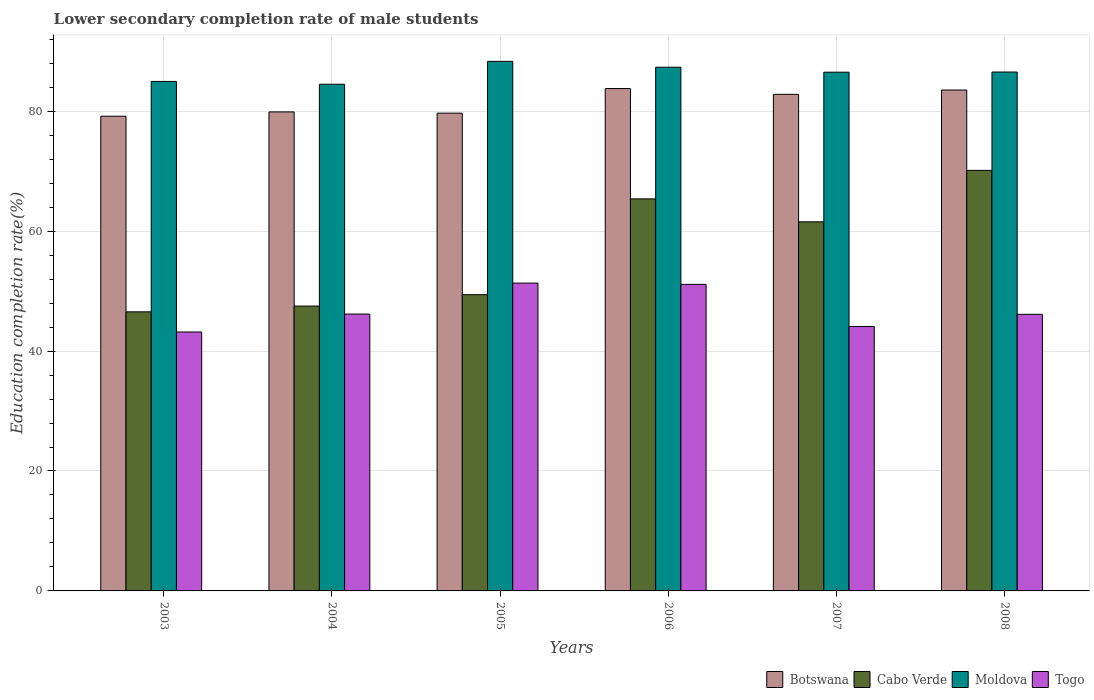How many different coloured bars are there?
Provide a succinct answer. 4. Are the number of bars per tick equal to the number of legend labels?
Keep it short and to the point. Yes. How many bars are there on the 1st tick from the left?
Your response must be concise. 4. How many bars are there on the 5th tick from the right?
Offer a terse response. 4. In how many cases, is the number of bars for a given year not equal to the number of legend labels?
Provide a short and direct response. 0. What is the lower secondary completion rate of male students in Togo in 2006?
Your answer should be compact. 51.13. Across all years, what is the maximum lower secondary completion rate of male students in Togo?
Provide a short and direct response. 51.34. Across all years, what is the minimum lower secondary completion rate of male students in Cabo Verde?
Provide a short and direct response. 46.54. What is the total lower secondary completion rate of male students in Botswana in the graph?
Give a very brief answer. 488.87. What is the difference between the lower secondary completion rate of male students in Moldova in 2006 and that in 2008?
Your answer should be compact. 0.8. What is the difference between the lower secondary completion rate of male students in Botswana in 2007 and the lower secondary completion rate of male students in Moldova in 2004?
Offer a terse response. -1.68. What is the average lower secondary completion rate of male students in Moldova per year?
Provide a short and direct response. 86.36. In the year 2003, what is the difference between the lower secondary completion rate of male students in Moldova and lower secondary completion rate of male students in Cabo Verde?
Your answer should be very brief. 38.43. What is the ratio of the lower secondary completion rate of male students in Cabo Verde in 2004 to that in 2007?
Your answer should be very brief. 0.77. Is the lower secondary completion rate of male students in Togo in 2004 less than that in 2005?
Your response must be concise. Yes. Is the difference between the lower secondary completion rate of male students in Moldova in 2005 and 2007 greater than the difference between the lower secondary completion rate of male students in Cabo Verde in 2005 and 2007?
Offer a terse response. Yes. What is the difference between the highest and the second highest lower secondary completion rate of male students in Botswana?
Provide a succinct answer. 0.25. What is the difference between the highest and the lowest lower secondary completion rate of male students in Moldova?
Offer a terse response. 3.82. Is the sum of the lower secondary completion rate of male students in Togo in 2006 and 2008 greater than the maximum lower secondary completion rate of male students in Moldova across all years?
Provide a succinct answer. Yes. What does the 3rd bar from the left in 2004 represents?
Offer a very short reply. Moldova. What does the 4th bar from the right in 2007 represents?
Provide a succinct answer. Botswana. Is it the case that in every year, the sum of the lower secondary completion rate of male students in Togo and lower secondary completion rate of male students in Cabo Verde is greater than the lower secondary completion rate of male students in Moldova?
Offer a terse response. Yes. How many bars are there?
Your answer should be compact. 24. Are all the bars in the graph horizontal?
Your answer should be compact. No. How many years are there in the graph?
Offer a terse response. 6. Are the values on the major ticks of Y-axis written in scientific E-notation?
Give a very brief answer. No. Does the graph contain any zero values?
Offer a very short reply. No. Where does the legend appear in the graph?
Provide a short and direct response. Bottom right. How many legend labels are there?
Your response must be concise. 4. How are the legend labels stacked?
Offer a very short reply. Horizontal. What is the title of the graph?
Provide a short and direct response. Lower secondary completion rate of male students. Does "St. Lucia" appear as one of the legend labels in the graph?
Your response must be concise. No. What is the label or title of the X-axis?
Provide a succinct answer. Years. What is the label or title of the Y-axis?
Ensure brevity in your answer.  Education completion rate(%). What is the Education completion rate(%) in Botswana in 2003?
Make the answer very short. 79.17. What is the Education completion rate(%) of Cabo Verde in 2003?
Provide a short and direct response. 46.54. What is the Education completion rate(%) of Moldova in 2003?
Ensure brevity in your answer.  84.97. What is the Education completion rate(%) of Togo in 2003?
Give a very brief answer. 43.18. What is the Education completion rate(%) of Botswana in 2004?
Give a very brief answer. 79.89. What is the Education completion rate(%) of Cabo Verde in 2004?
Your response must be concise. 47.51. What is the Education completion rate(%) in Moldova in 2004?
Ensure brevity in your answer.  84.5. What is the Education completion rate(%) of Togo in 2004?
Offer a terse response. 46.17. What is the Education completion rate(%) in Botswana in 2005?
Offer a terse response. 79.68. What is the Education completion rate(%) of Cabo Verde in 2005?
Keep it short and to the point. 49.41. What is the Education completion rate(%) of Moldova in 2005?
Give a very brief answer. 88.32. What is the Education completion rate(%) in Togo in 2005?
Ensure brevity in your answer.  51.34. What is the Education completion rate(%) in Botswana in 2006?
Offer a terse response. 83.78. What is the Education completion rate(%) of Cabo Verde in 2006?
Provide a short and direct response. 65.38. What is the Education completion rate(%) of Moldova in 2006?
Provide a short and direct response. 87.34. What is the Education completion rate(%) in Togo in 2006?
Your answer should be very brief. 51.13. What is the Education completion rate(%) in Botswana in 2007?
Your response must be concise. 82.82. What is the Education completion rate(%) of Cabo Verde in 2007?
Provide a succinct answer. 61.55. What is the Education completion rate(%) of Moldova in 2007?
Keep it short and to the point. 86.51. What is the Education completion rate(%) in Togo in 2007?
Your response must be concise. 44.1. What is the Education completion rate(%) of Botswana in 2008?
Your answer should be very brief. 83.54. What is the Education completion rate(%) of Cabo Verde in 2008?
Keep it short and to the point. 70.13. What is the Education completion rate(%) of Moldova in 2008?
Keep it short and to the point. 86.53. What is the Education completion rate(%) in Togo in 2008?
Offer a very short reply. 46.13. Across all years, what is the maximum Education completion rate(%) of Botswana?
Make the answer very short. 83.78. Across all years, what is the maximum Education completion rate(%) in Cabo Verde?
Keep it short and to the point. 70.13. Across all years, what is the maximum Education completion rate(%) of Moldova?
Make the answer very short. 88.32. Across all years, what is the maximum Education completion rate(%) of Togo?
Your response must be concise. 51.34. Across all years, what is the minimum Education completion rate(%) in Botswana?
Provide a short and direct response. 79.17. Across all years, what is the minimum Education completion rate(%) of Cabo Verde?
Keep it short and to the point. 46.54. Across all years, what is the minimum Education completion rate(%) of Moldova?
Your answer should be very brief. 84.5. Across all years, what is the minimum Education completion rate(%) in Togo?
Your response must be concise. 43.18. What is the total Education completion rate(%) in Botswana in the graph?
Your response must be concise. 488.87. What is the total Education completion rate(%) in Cabo Verde in the graph?
Ensure brevity in your answer.  340.53. What is the total Education completion rate(%) in Moldova in the graph?
Make the answer very short. 518.17. What is the total Education completion rate(%) of Togo in the graph?
Provide a short and direct response. 282.05. What is the difference between the Education completion rate(%) in Botswana in 2003 and that in 2004?
Make the answer very short. -0.72. What is the difference between the Education completion rate(%) in Cabo Verde in 2003 and that in 2004?
Offer a very short reply. -0.96. What is the difference between the Education completion rate(%) of Moldova in 2003 and that in 2004?
Offer a terse response. 0.47. What is the difference between the Education completion rate(%) of Togo in 2003 and that in 2004?
Keep it short and to the point. -2.99. What is the difference between the Education completion rate(%) of Botswana in 2003 and that in 2005?
Your answer should be compact. -0.51. What is the difference between the Education completion rate(%) in Cabo Verde in 2003 and that in 2005?
Your answer should be compact. -2.86. What is the difference between the Education completion rate(%) in Moldova in 2003 and that in 2005?
Ensure brevity in your answer.  -3.35. What is the difference between the Education completion rate(%) in Togo in 2003 and that in 2005?
Keep it short and to the point. -8.15. What is the difference between the Education completion rate(%) in Botswana in 2003 and that in 2006?
Make the answer very short. -4.61. What is the difference between the Education completion rate(%) in Cabo Verde in 2003 and that in 2006?
Make the answer very short. -18.84. What is the difference between the Education completion rate(%) in Moldova in 2003 and that in 2006?
Provide a short and direct response. -2.37. What is the difference between the Education completion rate(%) of Togo in 2003 and that in 2006?
Ensure brevity in your answer.  -7.94. What is the difference between the Education completion rate(%) of Botswana in 2003 and that in 2007?
Ensure brevity in your answer.  -3.65. What is the difference between the Education completion rate(%) of Cabo Verde in 2003 and that in 2007?
Give a very brief answer. -15.01. What is the difference between the Education completion rate(%) in Moldova in 2003 and that in 2007?
Keep it short and to the point. -1.54. What is the difference between the Education completion rate(%) of Togo in 2003 and that in 2007?
Make the answer very short. -0.92. What is the difference between the Education completion rate(%) of Botswana in 2003 and that in 2008?
Your answer should be very brief. -4.37. What is the difference between the Education completion rate(%) of Cabo Verde in 2003 and that in 2008?
Provide a short and direct response. -23.59. What is the difference between the Education completion rate(%) of Moldova in 2003 and that in 2008?
Your response must be concise. -1.56. What is the difference between the Education completion rate(%) in Togo in 2003 and that in 2008?
Provide a short and direct response. -2.95. What is the difference between the Education completion rate(%) in Botswana in 2004 and that in 2005?
Give a very brief answer. 0.21. What is the difference between the Education completion rate(%) of Cabo Verde in 2004 and that in 2005?
Make the answer very short. -1.9. What is the difference between the Education completion rate(%) in Moldova in 2004 and that in 2005?
Make the answer very short. -3.82. What is the difference between the Education completion rate(%) in Togo in 2004 and that in 2005?
Your answer should be compact. -5.17. What is the difference between the Education completion rate(%) of Botswana in 2004 and that in 2006?
Make the answer very short. -3.9. What is the difference between the Education completion rate(%) in Cabo Verde in 2004 and that in 2006?
Offer a very short reply. -17.87. What is the difference between the Education completion rate(%) in Moldova in 2004 and that in 2006?
Your answer should be compact. -2.84. What is the difference between the Education completion rate(%) in Togo in 2004 and that in 2006?
Make the answer very short. -4.95. What is the difference between the Education completion rate(%) of Botswana in 2004 and that in 2007?
Ensure brevity in your answer.  -2.93. What is the difference between the Education completion rate(%) in Cabo Verde in 2004 and that in 2007?
Provide a succinct answer. -14.05. What is the difference between the Education completion rate(%) in Moldova in 2004 and that in 2007?
Keep it short and to the point. -2.01. What is the difference between the Education completion rate(%) in Togo in 2004 and that in 2007?
Make the answer very short. 2.07. What is the difference between the Education completion rate(%) of Botswana in 2004 and that in 2008?
Offer a terse response. -3.65. What is the difference between the Education completion rate(%) of Cabo Verde in 2004 and that in 2008?
Ensure brevity in your answer.  -22.62. What is the difference between the Education completion rate(%) of Moldova in 2004 and that in 2008?
Your answer should be compact. -2.04. What is the difference between the Education completion rate(%) in Togo in 2004 and that in 2008?
Offer a very short reply. 0.04. What is the difference between the Education completion rate(%) of Botswana in 2005 and that in 2006?
Offer a terse response. -4.1. What is the difference between the Education completion rate(%) in Cabo Verde in 2005 and that in 2006?
Ensure brevity in your answer.  -15.97. What is the difference between the Education completion rate(%) of Moldova in 2005 and that in 2006?
Your answer should be very brief. 0.98. What is the difference between the Education completion rate(%) in Togo in 2005 and that in 2006?
Make the answer very short. 0.21. What is the difference between the Education completion rate(%) in Botswana in 2005 and that in 2007?
Offer a terse response. -3.14. What is the difference between the Education completion rate(%) in Cabo Verde in 2005 and that in 2007?
Give a very brief answer. -12.15. What is the difference between the Education completion rate(%) in Moldova in 2005 and that in 2007?
Offer a very short reply. 1.81. What is the difference between the Education completion rate(%) in Togo in 2005 and that in 2007?
Keep it short and to the point. 7.24. What is the difference between the Education completion rate(%) in Botswana in 2005 and that in 2008?
Your answer should be compact. -3.86. What is the difference between the Education completion rate(%) of Cabo Verde in 2005 and that in 2008?
Give a very brief answer. -20.73. What is the difference between the Education completion rate(%) in Moldova in 2005 and that in 2008?
Your response must be concise. 1.78. What is the difference between the Education completion rate(%) in Togo in 2005 and that in 2008?
Provide a short and direct response. 5.21. What is the difference between the Education completion rate(%) of Botswana in 2006 and that in 2007?
Provide a short and direct response. 0.97. What is the difference between the Education completion rate(%) of Cabo Verde in 2006 and that in 2007?
Provide a short and direct response. 3.83. What is the difference between the Education completion rate(%) in Moldova in 2006 and that in 2007?
Make the answer very short. 0.83. What is the difference between the Education completion rate(%) of Togo in 2006 and that in 2007?
Ensure brevity in your answer.  7.02. What is the difference between the Education completion rate(%) in Botswana in 2006 and that in 2008?
Ensure brevity in your answer.  0.25. What is the difference between the Education completion rate(%) in Cabo Verde in 2006 and that in 2008?
Give a very brief answer. -4.75. What is the difference between the Education completion rate(%) of Moldova in 2006 and that in 2008?
Provide a succinct answer. 0.8. What is the difference between the Education completion rate(%) of Togo in 2006 and that in 2008?
Keep it short and to the point. 5. What is the difference between the Education completion rate(%) in Botswana in 2007 and that in 2008?
Make the answer very short. -0.72. What is the difference between the Education completion rate(%) in Cabo Verde in 2007 and that in 2008?
Offer a terse response. -8.58. What is the difference between the Education completion rate(%) in Moldova in 2007 and that in 2008?
Your answer should be very brief. -0.03. What is the difference between the Education completion rate(%) of Togo in 2007 and that in 2008?
Provide a short and direct response. -2.03. What is the difference between the Education completion rate(%) of Botswana in 2003 and the Education completion rate(%) of Cabo Verde in 2004?
Offer a terse response. 31.66. What is the difference between the Education completion rate(%) in Botswana in 2003 and the Education completion rate(%) in Moldova in 2004?
Your response must be concise. -5.33. What is the difference between the Education completion rate(%) in Botswana in 2003 and the Education completion rate(%) in Togo in 2004?
Provide a succinct answer. 33. What is the difference between the Education completion rate(%) of Cabo Verde in 2003 and the Education completion rate(%) of Moldova in 2004?
Give a very brief answer. -37.95. What is the difference between the Education completion rate(%) of Cabo Verde in 2003 and the Education completion rate(%) of Togo in 2004?
Offer a terse response. 0.37. What is the difference between the Education completion rate(%) of Moldova in 2003 and the Education completion rate(%) of Togo in 2004?
Your answer should be compact. 38.8. What is the difference between the Education completion rate(%) of Botswana in 2003 and the Education completion rate(%) of Cabo Verde in 2005?
Your response must be concise. 29.76. What is the difference between the Education completion rate(%) in Botswana in 2003 and the Education completion rate(%) in Moldova in 2005?
Your answer should be very brief. -9.15. What is the difference between the Education completion rate(%) of Botswana in 2003 and the Education completion rate(%) of Togo in 2005?
Ensure brevity in your answer.  27.83. What is the difference between the Education completion rate(%) in Cabo Verde in 2003 and the Education completion rate(%) in Moldova in 2005?
Your response must be concise. -41.77. What is the difference between the Education completion rate(%) of Cabo Verde in 2003 and the Education completion rate(%) of Togo in 2005?
Provide a short and direct response. -4.79. What is the difference between the Education completion rate(%) of Moldova in 2003 and the Education completion rate(%) of Togo in 2005?
Keep it short and to the point. 33.63. What is the difference between the Education completion rate(%) in Botswana in 2003 and the Education completion rate(%) in Cabo Verde in 2006?
Keep it short and to the point. 13.79. What is the difference between the Education completion rate(%) in Botswana in 2003 and the Education completion rate(%) in Moldova in 2006?
Provide a short and direct response. -8.17. What is the difference between the Education completion rate(%) in Botswana in 2003 and the Education completion rate(%) in Togo in 2006?
Offer a very short reply. 28.04. What is the difference between the Education completion rate(%) of Cabo Verde in 2003 and the Education completion rate(%) of Moldova in 2006?
Your response must be concise. -40.8. What is the difference between the Education completion rate(%) of Cabo Verde in 2003 and the Education completion rate(%) of Togo in 2006?
Provide a short and direct response. -4.58. What is the difference between the Education completion rate(%) of Moldova in 2003 and the Education completion rate(%) of Togo in 2006?
Give a very brief answer. 33.84. What is the difference between the Education completion rate(%) in Botswana in 2003 and the Education completion rate(%) in Cabo Verde in 2007?
Keep it short and to the point. 17.61. What is the difference between the Education completion rate(%) in Botswana in 2003 and the Education completion rate(%) in Moldova in 2007?
Your answer should be compact. -7.34. What is the difference between the Education completion rate(%) of Botswana in 2003 and the Education completion rate(%) of Togo in 2007?
Offer a very short reply. 35.07. What is the difference between the Education completion rate(%) in Cabo Verde in 2003 and the Education completion rate(%) in Moldova in 2007?
Offer a terse response. -39.97. What is the difference between the Education completion rate(%) in Cabo Verde in 2003 and the Education completion rate(%) in Togo in 2007?
Give a very brief answer. 2.44. What is the difference between the Education completion rate(%) in Moldova in 2003 and the Education completion rate(%) in Togo in 2007?
Keep it short and to the point. 40.87. What is the difference between the Education completion rate(%) in Botswana in 2003 and the Education completion rate(%) in Cabo Verde in 2008?
Provide a short and direct response. 9.04. What is the difference between the Education completion rate(%) of Botswana in 2003 and the Education completion rate(%) of Moldova in 2008?
Ensure brevity in your answer.  -7.37. What is the difference between the Education completion rate(%) of Botswana in 2003 and the Education completion rate(%) of Togo in 2008?
Make the answer very short. 33.04. What is the difference between the Education completion rate(%) in Cabo Verde in 2003 and the Education completion rate(%) in Moldova in 2008?
Make the answer very short. -39.99. What is the difference between the Education completion rate(%) in Cabo Verde in 2003 and the Education completion rate(%) in Togo in 2008?
Your answer should be very brief. 0.41. What is the difference between the Education completion rate(%) of Moldova in 2003 and the Education completion rate(%) of Togo in 2008?
Ensure brevity in your answer.  38.84. What is the difference between the Education completion rate(%) of Botswana in 2004 and the Education completion rate(%) of Cabo Verde in 2005?
Offer a very short reply. 30.48. What is the difference between the Education completion rate(%) of Botswana in 2004 and the Education completion rate(%) of Moldova in 2005?
Offer a terse response. -8.43. What is the difference between the Education completion rate(%) in Botswana in 2004 and the Education completion rate(%) in Togo in 2005?
Your answer should be compact. 28.55. What is the difference between the Education completion rate(%) in Cabo Verde in 2004 and the Education completion rate(%) in Moldova in 2005?
Make the answer very short. -40.81. What is the difference between the Education completion rate(%) in Cabo Verde in 2004 and the Education completion rate(%) in Togo in 2005?
Your response must be concise. -3.83. What is the difference between the Education completion rate(%) in Moldova in 2004 and the Education completion rate(%) in Togo in 2005?
Your answer should be very brief. 33.16. What is the difference between the Education completion rate(%) in Botswana in 2004 and the Education completion rate(%) in Cabo Verde in 2006?
Offer a terse response. 14.5. What is the difference between the Education completion rate(%) in Botswana in 2004 and the Education completion rate(%) in Moldova in 2006?
Give a very brief answer. -7.45. What is the difference between the Education completion rate(%) of Botswana in 2004 and the Education completion rate(%) of Togo in 2006?
Offer a very short reply. 28.76. What is the difference between the Education completion rate(%) in Cabo Verde in 2004 and the Education completion rate(%) in Moldova in 2006?
Your response must be concise. -39.83. What is the difference between the Education completion rate(%) in Cabo Verde in 2004 and the Education completion rate(%) in Togo in 2006?
Offer a terse response. -3.62. What is the difference between the Education completion rate(%) of Moldova in 2004 and the Education completion rate(%) of Togo in 2006?
Your response must be concise. 33.37. What is the difference between the Education completion rate(%) of Botswana in 2004 and the Education completion rate(%) of Cabo Verde in 2007?
Ensure brevity in your answer.  18.33. What is the difference between the Education completion rate(%) of Botswana in 2004 and the Education completion rate(%) of Moldova in 2007?
Your answer should be very brief. -6.62. What is the difference between the Education completion rate(%) in Botswana in 2004 and the Education completion rate(%) in Togo in 2007?
Your answer should be compact. 35.78. What is the difference between the Education completion rate(%) of Cabo Verde in 2004 and the Education completion rate(%) of Moldova in 2007?
Make the answer very short. -39. What is the difference between the Education completion rate(%) of Cabo Verde in 2004 and the Education completion rate(%) of Togo in 2007?
Your answer should be compact. 3.41. What is the difference between the Education completion rate(%) in Moldova in 2004 and the Education completion rate(%) in Togo in 2007?
Your answer should be very brief. 40.4. What is the difference between the Education completion rate(%) of Botswana in 2004 and the Education completion rate(%) of Cabo Verde in 2008?
Keep it short and to the point. 9.75. What is the difference between the Education completion rate(%) of Botswana in 2004 and the Education completion rate(%) of Moldova in 2008?
Your response must be concise. -6.65. What is the difference between the Education completion rate(%) in Botswana in 2004 and the Education completion rate(%) in Togo in 2008?
Provide a succinct answer. 33.76. What is the difference between the Education completion rate(%) in Cabo Verde in 2004 and the Education completion rate(%) in Moldova in 2008?
Make the answer very short. -39.03. What is the difference between the Education completion rate(%) of Cabo Verde in 2004 and the Education completion rate(%) of Togo in 2008?
Offer a terse response. 1.38. What is the difference between the Education completion rate(%) of Moldova in 2004 and the Education completion rate(%) of Togo in 2008?
Ensure brevity in your answer.  38.37. What is the difference between the Education completion rate(%) of Botswana in 2005 and the Education completion rate(%) of Cabo Verde in 2006?
Offer a very short reply. 14.3. What is the difference between the Education completion rate(%) in Botswana in 2005 and the Education completion rate(%) in Moldova in 2006?
Keep it short and to the point. -7.66. What is the difference between the Education completion rate(%) of Botswana in 2005 and the Education completion rate(%) of Togo in 2006?
Your answer should be very brief. 28.55. What is the difference between the Education completion rate(%) of Cabo Verde in 2005 and the Education completion rate(%) of Moldova in 2006?
Your answer should be compact. -37.93. What is the difference between the Education completion rate(%) of Cabo Verde in 2005 and the Education completion rate(%) of Togo in 2006?
Provide a short and direct response. -1.72. What is the difference between the Education completion rate(%) of Moldova in 2005 and the Education completion rate(%) of Togo in 2006?
Your response must be concise. 37.19. What is the difference between the Education completion rate(%) in Botswana in 2005 and the Education completion rate(%) in Cabo Verde in 2007?
Keep it short and to the point. 18.12. What is the difference between the Education completion rate(%) in Botswana in 2005 and the Education completion rate(%) in Moldova in 2007?
Offer a terse response. -6.83. What is the difference between the Education completion rate(%) of Botswana in 2005 and the Education completion rate(%) of Togo in 2007?
Give a very brief answer. 35.58. What is the difference between the Education completion rate(%) in Cabo Verde in 2005 and the Education completion rate(%) in Moldova in 2007?
Keep it short and to the point. -37.1. What is the difference between the Education completion rate(%) of Cabo Verde in 2005 and the Education completion rate(%) of Togo in 2007?
Ensure brevity in your answer.  5.31. What is the difference between the Education completion rate(%) in Moldova in 2005 and the Education completion rate(%) in Togo in 2007?
Give a very brief answer. 44.22. What is the difference between the Education completion rate(%) in Botswana in 2005 and the Education completion rate(%) in Cabo Verde in 2008?
Provide a succinct answer. 9.55. What is the difference between the Education completion rate(%) of Botswana in 2005 and the Education completion rate(%) of Moldova in 2008?
Ensure brevity in your answer.  -6.86. What is the difference between the Education completion rate(%) of Botswana in 2005 and the Education completion rate(%) of Togo in 2008?
Your answer should be very brief. 33.55. What is the difference between the Education completion rate(%) in Cabo Verde in 2005 and the Education completion rate(%) in Moldova in 2008?
Make the answer very short. -37.13. What is the difference between the Education completion rate(%) in Cabo Verde in 2005 and the Education completion rate(%) in Togo in 2008?
Offer a terse response. 3.28. What is the difference between the Education completion rate(%) of Moldova in 2005 and the Education completion rate(%) of Togo in 2008?
Give a very brief answer. 42.19. What is the difference between the Education completion rate(%) in Botswana in 2006 and the Education completion rate(%) in Cabo Verde in 2007?
Your answer should be compact. 22.23. What is the difference between the Education completion rate(%) in Botswana in 2006 and the Education completion rate(%) in Moldova in 2007?
Offer a terse response. -2.73. What is the difference between the Education completion rate(%) in Botswana in 2006 and the Education completion rate(%) in Togo in 2007?
Offer a terse response. 39.68. What is the difference between the Education completion rate(%) of Cabo Verde in 2006 and the Education completion rate(%) of Moldova in 2007?
Provide a short and direct response. -21.13. What is the difference between the Education completion rate(%) in Cabo Verde in 2006 and the Education completion rate(%) in Togo in 2007?
Make the answer very short. 21.28. What is the difference between the Education completion rate(%) of Moldova in 2006 and the Education completion rate(%) of Togo in 2007?
Offer a very short reply. 43.24. What is the difference between the Education completion rate(%) of Botswana in 2006 and the Education completion rate(%) of Cabo Verde in 2008?
Offer a terse response. 13.65. What is the difference between the Education completion rate(%) of Botswana in 2006 and the Education completion rate(%) of Moldova in 2008?
Your answer should be compact. -2.75. What is the difference between the Education completion rate(%) of Botswana in 2006 and the Education completion rate(%) of Togo in 2008?
Provide a succinct answer. 37.65. What is the difference between the Education completion rate(%) of Cabo Verde in 2006 and the Education completion rate(%) of Moldova in 2008?
Provide a succinct answer. -21.15. What is the difference between the Education completion rate(%) in Cabo Verde in 2006 and the Education completion rate(%) in Togo in 2008?
Offer a very short reply. 19.25. What is the difference between the Education completion rate(%) in Moldova in 2006 and the Education completion rate(%) in Togo in 2008?
Provide a short and direct response. 41.21. What is the difference between the Education completion rate(%) in Botswana in 2007 and the Education completion rate(%) in Cabo Verde in 2008?
Your response must be concise. 12.68. What is the difference between the Education completion rate(%) in Botswana in 2007 and the Education completion rate(%) in Moldova in 2008?
Ensure brevity in your answer.  -3.72. What is the difference between the Education completion rate(%) of Botswana in 2007 and the Education completion rate(%) of Togo in 2008?
Ensure brevity in your answer.  36.69. What is the difference between the Education completion rate(%) in Cabo Verde in 2007 and the Education completion rate(%) in Moldova in 2008?
Make the answer very short. -24.98. What is the difference between the Education completion rate(%) in Cabo Verde in 2007 and the Education completion rate(%) in Togo in 2008?
Your answer should be very brief. 15.43. What is the difference between the Education completion rate(%) of Moldova in 2007 and the Education completion rate(%) of Togo in 2008?
Your answer should be compact. 40.38. What is the average Education completion rate(%) in Botswana per year?
Your answer should be compact. 81.48. What is the average Education completion rate(%) of Cabo Verde per year?
Your answer should be very brief. 56.76. What is the average Education completion rate(%) of Moldova per year?
Provide a succinct answer. 86.36. What is the average Education completion rate(%) of Togo per year?
Give a very brief answer. 47.01. In the year 2003, what is the difference between the Education completion rate(%) in Botswana and Education completion rate(%) in Cabo Verde?
Your answer should be compact. 32.63. In the year 2003, what is the difference between the Education completion rate(%) in Botswana and Education completion rate(%) in Moldova?
Your response must be concise. -5.8. In the year 2003, what is the difference between the Education completion rate(%) in Botswana and Education completion rate(%) in Togo?
Provide a succinct answer. 35.99. In the year 2003, what is the difference between the Education completion rate(%) of Cabo Verde and Education completion rate(%) of Moldova?
Make the answer very short. -38.43. In the year 2003, what is the difference between the Education completion rate(%) in Cabo Verde and Education completion rate(%) in Togo?
Ensure brevity in your answer.  3.36. In the year 2003, what is the difference between the Education completion rate(%) in Moldova and Education completion rate(%) in Togo?
Your answer should be compact. 41.79. In the year 2004, what is the difference between the Education completion rate(%) of Botswana and Education completion rate(%) of Cabo Verde?
Your response must be concise. 32.38. In the year 2004, what is the difference between the Education completion rate(%) in Botswana and Education completion rate(%) in Moldova?
Give a very brief answer. -4.61. In the year 2004, what is the difference between the Education completion rate(%) of Botswana and Education completion rate(%) of Togo?
Give a very brief answer. 33.71. In the year 2004, what is the difference between the Education completion rate(%) of Cabo Verde and Education completion rate(%) of Moldova?
Ensure brevity in your answer.  -36.99. In the year 2004, what is the difference between the Education completion rate(%) of Cabo Verde and Education completion rate(%) of Togo?
Give a very brief answer. 1.34. In the year 2004, what is the difference between the Education completion rate(%) of Moldova and Education completion rate(%) of Togo?
Make the answer very short. 38.33. In the year 2005, what is the difference between the Education completion rate(%) of Botswana and Education completion rate(%) of Cabo Verde?
Provide a succinct answer. 30.27. In the year 2005, what is the difference between the Education completion rate(%) of Botswana and Education completion rate(%) of Moldova?
Ensure brevity in your answer.  -8.64. In the year 2005, what is the difference between the Education completion rate(%) of Botswana and Education completion rate(%) of Togo?
Provide a short and direct response. 28.34. In the year 2005, what is the difference between the Education completion rate(%) in Cabo Verde and Education completion rate(%) in Moldova?
Offer a very short reply. -38.91. In the year 2005, what is the difference between the Education completion rate(%) in Cabo Verde and Education completion rate(%) in Togo?
Your response must be concise. -1.93. In the year 2005, what is the difference between the Education completion rate(%) in Moldova and Education completion rate(%) in Togo?
Give a very brief answer. 36.98. In the year 2006, what is the difference between the Education completion rate(%) of Botswana and Education completion rate(%) of Cabo Verde?
Offer a terse response. 18.4. In the year 2006, what is the difference between the Education completion rate(%) in Botswana and Education completion rate(%) in Moldova?
Give a very brief answer. -3.56. In the year 2006, what is the difference between the Education completion rate(%) of Botswana and Education completion rate(%) of Togo?
Ensure brevity in your answer.  32.66. In the year 2006, what is the difference between the Education completion rate(%) in Cabo Verde and Education completion rate(%) in Moldova?
Ensure brevity in your answer.  -21.96. In the year 2006, what is the difference between the Education completion rate(%) of Cabo Verde and Education completion rate(%) of Togo?
Offer a very short reply. 14.26. In the year 2006, what is the difference between the Education completion rate(%) in Moldova and Education completion rate(%) in Togo?
Offer a terse response. 36.21. In the year 2007, what is the difference between the Education completion rate(%) of Botswana and Education completion rate(%) of Cabo Verde?
Your answer should be compact. 21.26. In the year 2007, what is the difference between the Education completion rate(%) in Botswana and Education completion rate(%) in Moldova?
Ensure brevity in your answer.  -3.69. In the year 2007, what is the difference between the Education completion rate(%) in Botswana and Education completion rate(%) in Togo?
Your answer should be very brief. 38.72. In the year 2007, what is the difference between the Education completion rate(%) in Cabo Verde and Education completion rate(%) in Moldova?
Ensure brevity in your answer.  -24.95. In the year 2007, what is the difference between the Education completion rate(%) in Cabo Verde and Education completion rate(%) in Togo?
Your answer should be very brief. 17.45. In the year 2007, what is the difference between the Education completion rate(%) in Moldova and Education completion rate(%) in Togo?
Make the answer very short. 42.41. In the year 2008, what is the difference between the Education completion rate(%) of Botswana and Education completion rate(%) of Cabo Verde?
Give a very brief answer. 13.4. In the year 2008, what is the difference between the Education completion rate(%) of Botswana and Education completion rate(%) of Moldova?
Provide a succinct answer. -3. In the year 2008, what is the difference between the Education completion rate(%) in Botswana and Education completion rate(%) in Togo?
Your answer should be very brief. 37.41. In the year 2008, what is the difference between the Education completion rate(%) of Cabo Verde and Education completion rate(%) of Moldova?
Your answer should be very brief. -16.4. In the year 2008, what is the difference between the Education completion rate(%) in Cabo Verde and Education completion rate(%) in Togo?
Give a very brief answer. 24. In the year 2008, what is the difference between the Education completion rate(%) of Moldova and Education completion rate(%) of Togo?
Make the answer very short. 40.4. What is the ratio of the Education completion rate(%) in Botswana in 2003 to that in 2004?
Offer a very short reply. 0.99. What is the ratio of the Education completion rate(%) in Cabo Verde in 2003 to that in 2004?
Keep it short and to the point. 0.98. What is the ratio of the Education completion rate(%) of Moldova in 2003 to that in 2004?
Offer a terse response. 1.01. What is the ratio of the Education completion rate(%) in Togo in 2003 to that in 2004?
Make the answer very short. 0.94. What is the ratio of the Education completion rate(%) in Botswana in 2003 to that in 2005?
Your answer should be compact. 0.99. What is the ratio of the Education completion rate(%) in Cabo Verde in 2003 to that in 2005?
Keep it short and to the point. 0.94. What is the ratio of the Education completion rate(%) of Moldova in 2003 to that in 2005?
Ensure brevity in your answer.  0.96. What is the ratio of the Education completion rate(%) of Togo in 2003 to that in 2005?
Your answer should be compact. 0.84. What is the ratio of the Education completion rate(%) of Botswana in 2003 to that in 2006?
Your answer should be very brief. 0.94. What is the ratio of the Education completion rate(%) of Cabo Verde in 2003 to that in 2006?
Give a very brief answer. 0.71. What is the ratio of the Education completion rate(%) in Moldova in 2003 to that in 2006?
Ensure brevity in your answer.  0.97. What is the ratio of the Education completion rate(%) in Togo in 2003 to that in 2006?
Ensure brevity in your answer.  0.84. What is the ratio of the Education completion rate(%) in Botswana in 2003 to that in 2007?
Give a very brief answer. 0.96. What is the ratio of the Education completion rate(%) of Cabo Verde in 2003 to that in 2007?
Offer a terse response. 0.76. What is the ratio of the Education completion rate(%) in Moldova in 2003 to that in 2007?
Offer a terse response. 0.98. What is the ratio of the Education completion rate(%) in Togo in 2003 to that in 2007?
Provide a succinct answer. 0.98. What is the ratio of the Education completion rate(%) in Botswana in 2003 to that in 2008?
Provide a succinct answer. 0.95. What is the ratio of the Education completion rate(%) of Cabo Verde in 2003 to that in 2008?
Keep it short and to the point. 0.66. What is the ratio of the Education completion rate(%) of Moldova in 2003 to that in 2008?
Your answer should be very brief. 0.98. What is the ratio of the Education completion rate(%) of Togo in 2003 to that in 2008?
Provide a succinct answer. 0.94. What is the ratio of the Education completion rate(%) of Cabo Verde in 2004 to that in 2005?
Keep it short and to the point. 0.96. What is the ratio of the Education completion rate(%) in Moldova in 2004 to that in 2005?
Your response must be concise. 0.96. What is the ratio of the Education completion rate(%) of Togo in 2004 to that in 2005?
Keep it short and to the point. 0.9. What is the ratio of the Education completion rate(%) in Botswana in 2004 to that in 2006?
Keep it short and to the point. 0.95. What is the ratio of the Education completion rate(%) of Cabo Verde in 2004 to that in 2006?
Provide a succinct answer. 0.73. What is the ratio of the Education completion rate(%) in Moldova in 2004 to that in 2006?
Give a very brief answer. 0.97. What is the ratio of the Education completion rate(%) in Togo in 2004 to that in 2006?
Your answer should be compact. 0.9. What is the ratio of the Education completion rate(%) in Botswana in 2004 to that in 2007?
Your response must be concise. 0.96. What is the ratio of the Education completion rate(%) of Cabo Verde in 2004 to that in 2007?
Ensure brevity in your answer.  0.77. What is the ratio of the Education completion rate(%) in Moldova in 2004 to that in 2007?
Offer a terse response. 0.98. What is the ratio of the Education completion rate(%) of Togo in 2004 to that in 2007?
Your answer should be very brief. 1.05. What is the ratio of the Education completion rate(%) of Botswana in 2004 to that in 2008?
Make the answer very short. 0.96. What is the ratio of the Education completion rate(%) in Cabo Verde in 2004 to that in 2008?
Give a very brief answer. 0.68. What is the ratio of the Education completion rate(%) of Moldova in 2004 to that in 2008?
Provide a short and direct response. 0.98. What is the ratio of the Education completion rate(%) of Togo in 2004 to that in 2008?
Offer a terse response. 1. What is the ratio of the Education completion rate(%) in Botswana in 2005 to that in 2006?
Ensure brevity in your answer.  0.95. What is the ratio of the Education completion rate(%) in Cabo Verde in 2005 to that in 2006?
Offer a terse response. 0.76. What is the ratio of the Education completion rate(%) of Moldova in 2005 to that in 2006?
Ensure brevity in your answer.  1.01. What is the ratio of the Education completion rate(%) of Botswana in 2005 to that in 2007?
Ensure brevity in your answer.  0.96. What is the ratio of the Education completion rate(%) in Cabo Verde in 2005 to that in 2007?
Offer a very short reply. 0.8. What is the ratio of the Education completion rate(%) of Moldova in 2005 to that in 2007?
Provide a succinct answer. 1.02. What is the ratio of the Education completion rate(%) of Togo in 2005 to that in 2007?
Your answer should be very brief. 1.16. What is the ratio of the Education completion rate(%) of Botswana in 2005 to that in 2008?
Make the answer very short. 0.95. What is the ratio of the Education completion rate(%) in Cabo Verde in 2005 to that in 2008?
Your response must be concise. 0.7. What is the ratio of the Education completion rate(%) in Moldova in 2005 to that in 2008?
Make the answer very short. 1.02. What is the ratio of the Education completion rate(%) of Togo in 2005 to that in 2008?
Your response must be concise. 1.11. What is the ratio of the Education completion rate(%) of Botswana in 2006 to that in 2007?
Your answer should be compact. 1.01. What is the ratio of the Education completion rate(%) in Cabo Verde in 2006 to that in 2007?
Keep it short and to the point. 1.06. What is the ratio of the Education completion rate(%) in Moldova in 2006 to that in 2007?
Your answer should be very brief. 1.01. What is the ratio of the Education completion rate(%) in Togo in 2006 to that in 2007?
Offer a very short reply. 1.16. What is the ratio of the Education completion rate(%) in Botswana in 2006 to that in 2008?
Make the answer very short. 1. What is the ratio of the Education completion rate(%) in Cabo Verde in 2006 to that in 2008?
Provide a succinct answer. 0.93. What is the ratio of the Education completion rate(%) of Moldova in 2006 to that in 2008?
Make the answer very short. 1.01. What is the ratio of the Education completion rate(%) of Togo in 2006 to that in 2008?
Your answer should be compact. 1.11. What is the ratio of the Education completion rate(%) in Botswana in 2007 to that in 2008?
Make the answer very short. 0.99. What is the ratio of the Education completion rate(%) in Cabo Verde in 2007 to that in 2008?
Offer a terse response. 0.88. What is the ratio of the Education completion rate(%) of Togo in 2007 to that in 2008?
Offer a very short reply. 0.96. What is the difference between the highest and the second highest Education completion rate(%) of Botswana?
Ensure brevity in your answer.  0.25. What is the difference between the highest and the second highest Education completion rate(%) in Cabo Verde?
Your answer should be compact. 4.75. What is the difference between the highest and the second highest Education completion rate(%) in Moldova?
Your response must be concise. 0.98. What is the difference between the highest and the second highest Education completion rate(%) of Togo?
Your response must be concise. 0.21. What is the difference between the highest and the lowest Education completion rate(%) in Botswana?
Offer a terse response. 4.61. What is the difference between the highest and the lowest Education completion rate(%) in Cabo Verde?
Keep it short and to the point. 23.59. What is the difference between the highest and the lowest Education completion rate(%) in Moldova?
Your response must be concise. 3.82. What is the difference between the highest and the lowest Education completion rate(%) of Togo?
Provide a succinct answer. 8.15. 